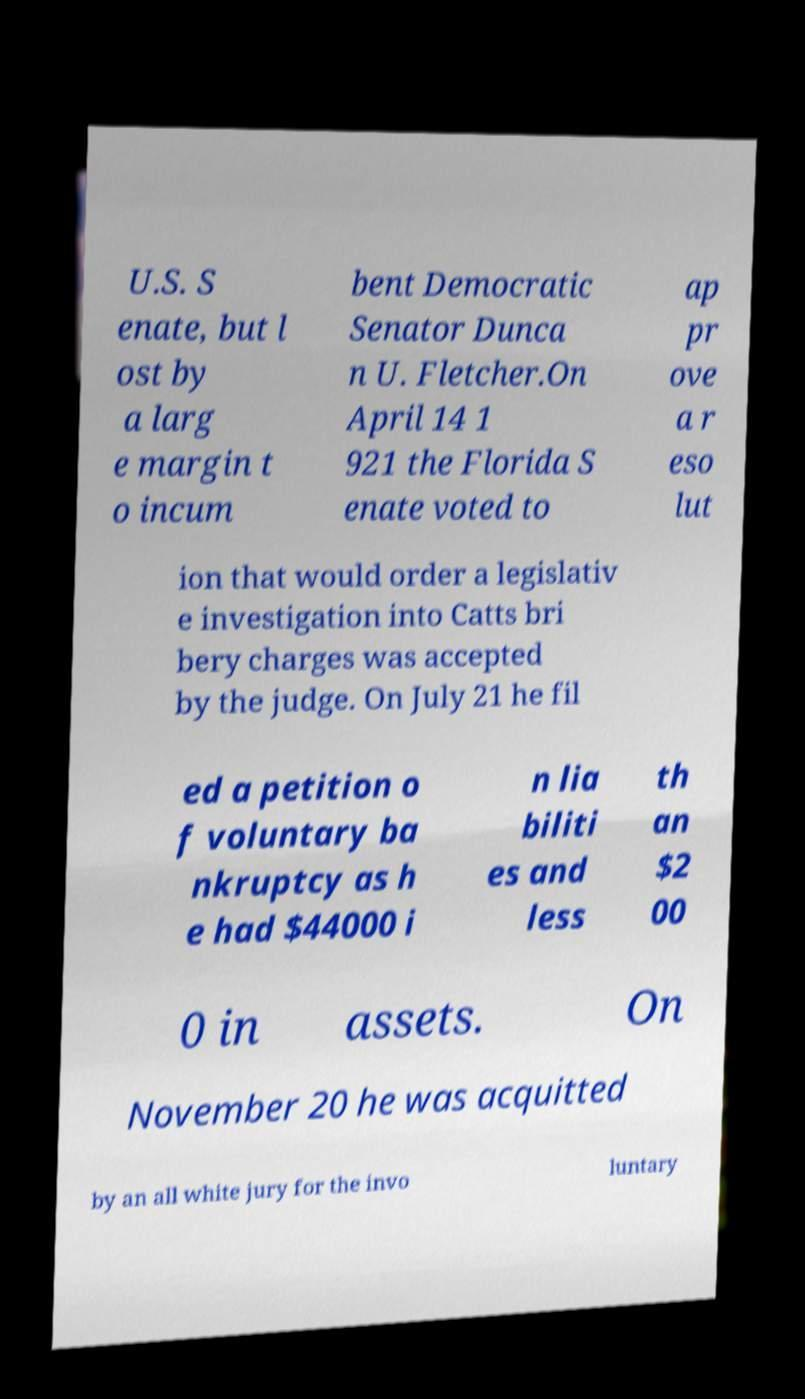Can you read and provide the text displayed in the image?This photo seems to have some interesting text. Can you extract and type it out for me? U.S. S enate, but l ost by a larg e margin t o incum bent Democratic Senator Dunca n U. Fletcher.On April 14 1 921 the Florida S enate voted to ap pr ove a r eso lut ion that would order a legislativ e investigation into Catts bri bery charges was accepted by the judge. On July 21 he fil ed a petition o f voluntary ba nkruptcy as h e had $44000 i n lia biliti es and less th an $2 00 0 in assets. On November 20 he was acquitted by an all white jury for the invo luntary 